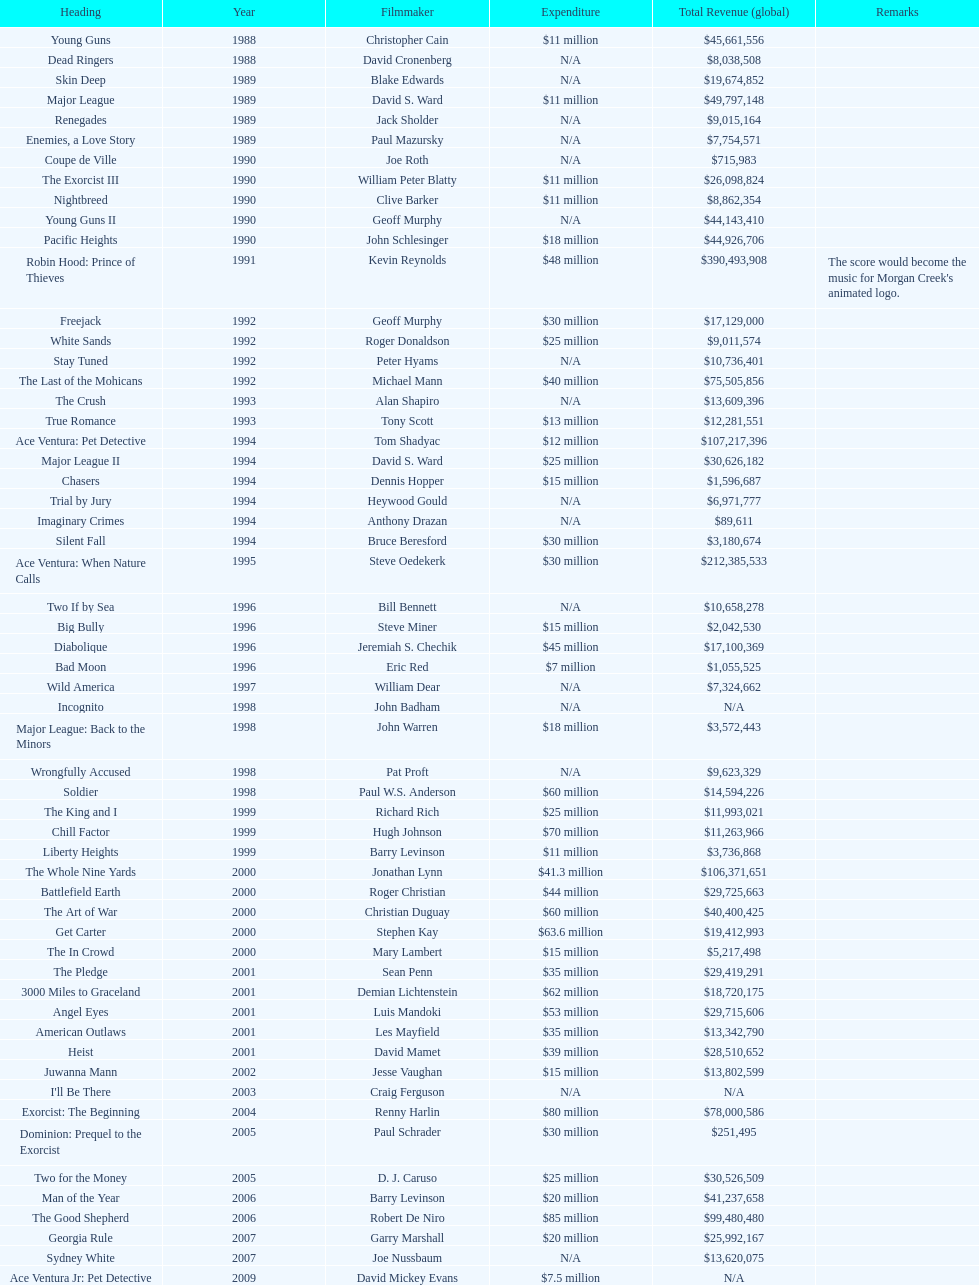Did true romance earn more or less revenue than diabolique? Less. 